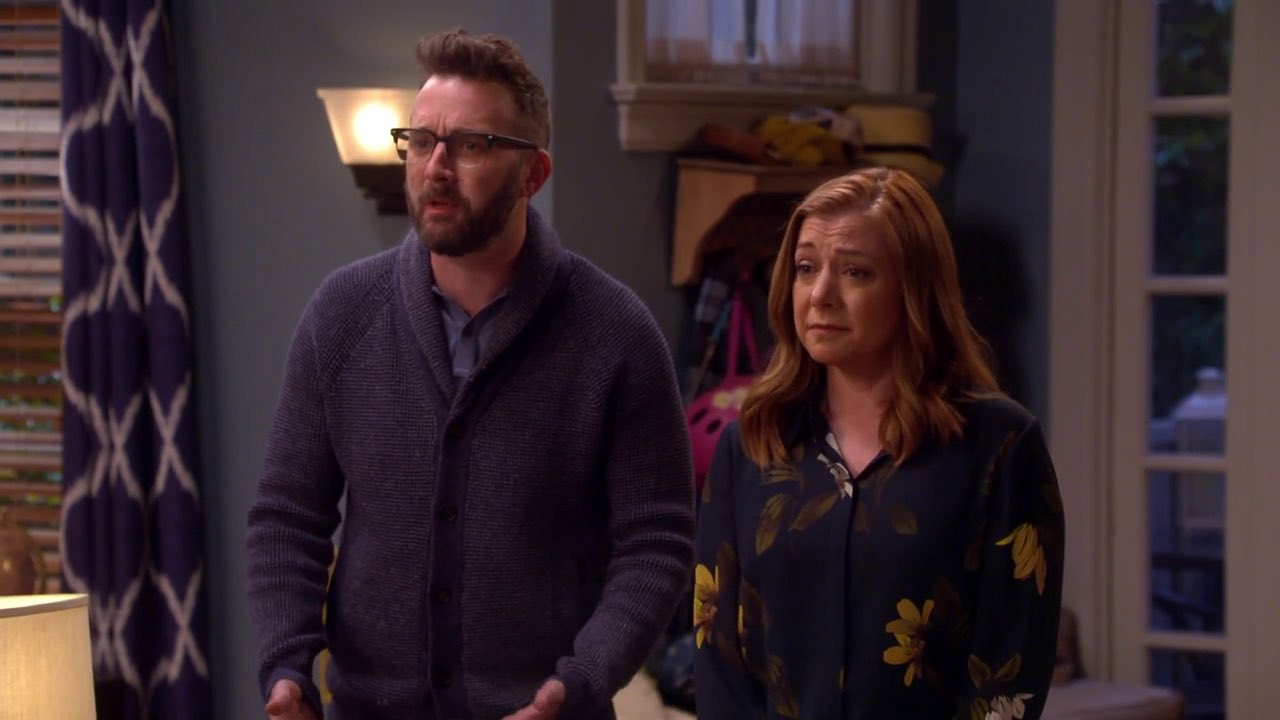What could they be discussing? The concerned expressions and the domestic setting suggest they might be discussing a personal issue. Possible topics could range from an unexpected visitor, a disturbing piece of news, or an urgent family matter. The man's open hands imply he could be emphasizing a point or explaining something significant. Do you think this is a tense moment? Yes, the scene does appear to be tense. Both individuals display worried expressions, and their attention is firmly fixed on something off-frame. The overall body language conveys a shared moment of concern or anxiety. 